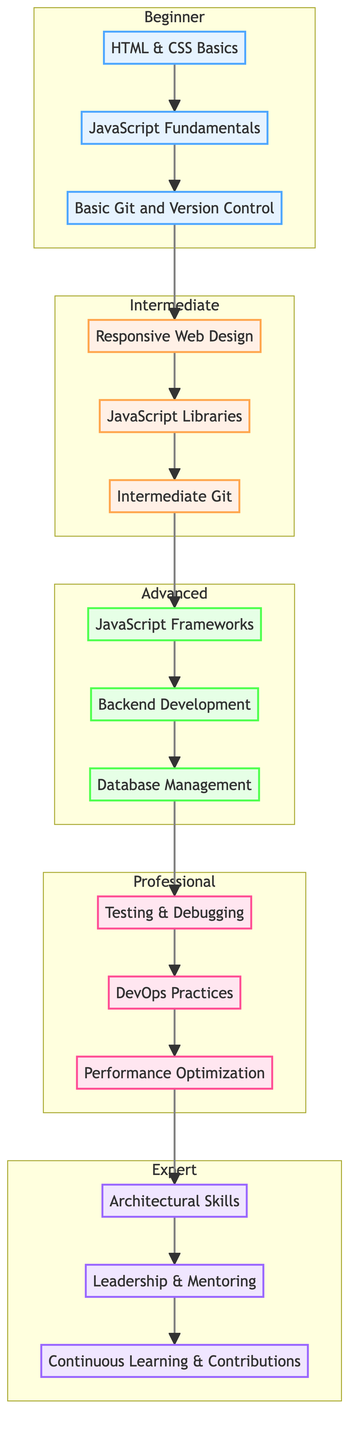What is the highest level in the flow chart? The flow chart represents various levels in a web developer's career. The highest level displayed is "Expert," which is located at the top of the diagram.
Answer: Expert How many milestones are there in the Intermediate level? The Intermediate level contains three specified milestones for web development progression: Responsive Web Design, JavaScript Libraries, and Intermediate Git.
Answer: 3 What milestone comes before Backend Development? To determine what comes before Backend Development, we look at the sequence. Before reaching the Advanced level's Backend Development milestone, one must complete JavaScript Frameworks and Database Management. Thus, the immediate predecessor is "JavaScript Frameworks."
Answer: JavaScript Frameworks In which level is Testing & Debugging located? By scanning the flow chart's various levels, one can see that Testing & Debugging is positioned in the Professional level, which is below the Expert level.
Answer: Professional Which sequence of milestones leads from HTML & CSS Basics to Leadership & Mentoring? To arrive at Leadership & Mentoring, we trace the flow upward starting from HTML & CSS Basics through each level's milestones: HTML & CSS Basics → JavaScript Fundamentals → Basic Git and Version Control → Responsive Web Design → JavaScript Libraries → Intermediate Git → JavaScript Frameworks → Backend Development → Database Management → Testing & Debugging → DevOps Practices → Performance Optimization → Leadership & Mentoring.
Answer: HTML & CSS Basics → Leadership & Mentoring What are the three milestones in the Expert level? The Expert level consists of three distinct milestones that signify advanced skills in web development. These are Architectural Skills, Leadership & Mentoring, and Continuous Learning & Contributions.
Answer: Architectural Skills, Leadership & Mentoring, Continuous Learning & Contributions How many subgraphs are present in the flow chart? The flow chart depicts five distinct subgraphs labeled for each career level, including Beginner, Intermediate, Advanced, Professional, and Expert. Each one focuses on a different stage in the web developer's journey.
Answer: 5 What is the color assigned to the Intermediate level? Upon reviewing the color coding established within the flow chart, the Intermediate level is assigned an orange color, specifically described in the diagram as "fill:#fff0e6."
Answer: orange Which milestone is at the bottom of the chart? The bottom-most milestone indicated on the chart is HTML & CSS Basics. This milestone represents the foundational step in a web developer's journey, thus it appears at the very start of the flow diagram.
Answer: HTML & CSS Basics 